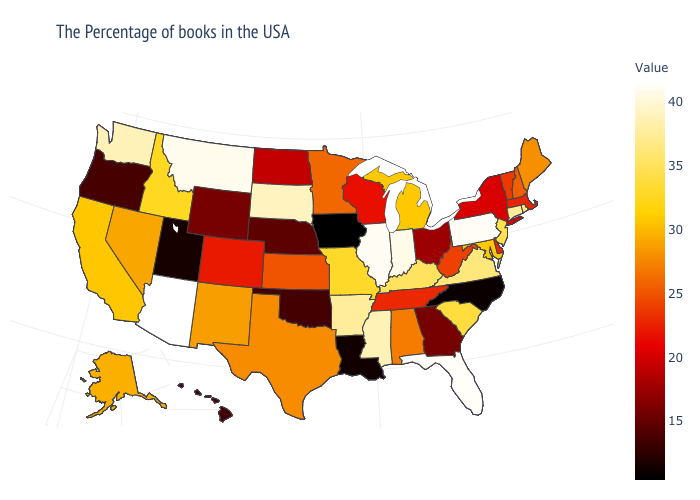Does North Carolina have the highest value in the USA?
Short answer required. No. Among the states that border Oregon , which have the highest value?
Keep it brief. Washington. Does the map have missing data?
Keep it brief. No. Which states have the lowest value in the USA?
Be succinct. Iowa. Does Iowa have the lowest value in the USA?
Concise answer only. Yes. Which states have the lowest value in the USA?
Keep it brief. Iowa. 